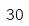Convert formula to latex. <formula><loc_0><loc_0><loc_500><loc_500>3 0</formula> 